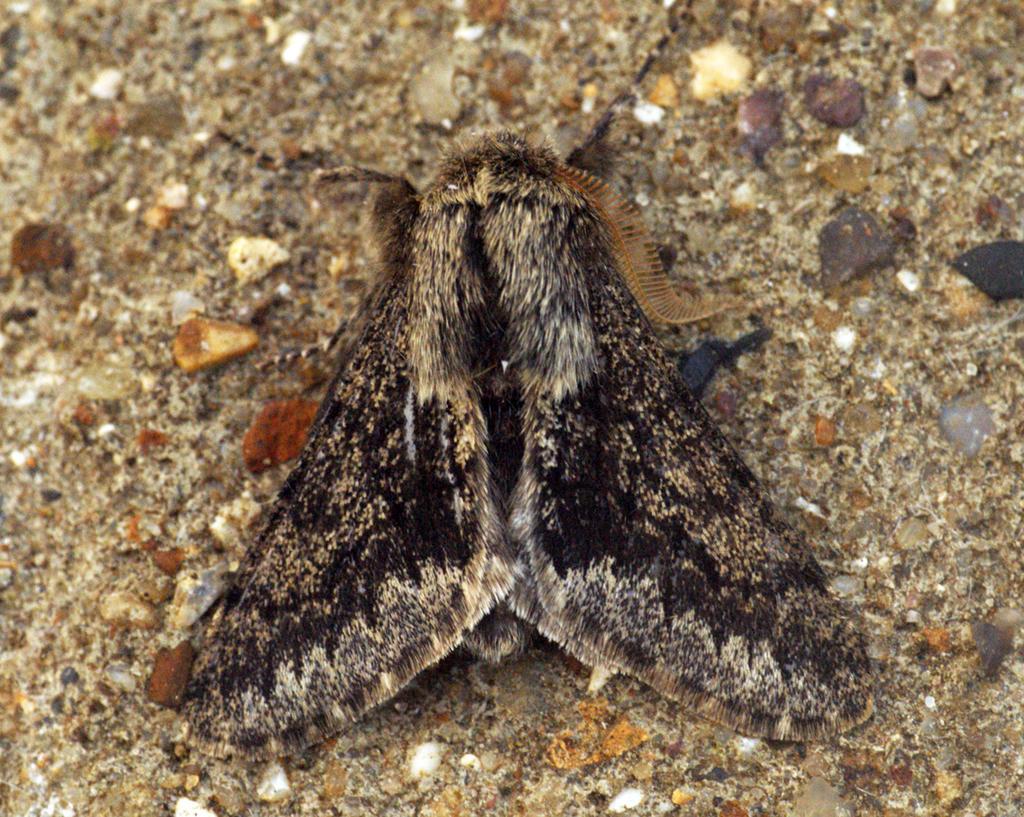Describe this image in one or two sentences. In this picture we can see an insect on the surface and we can see stones. 